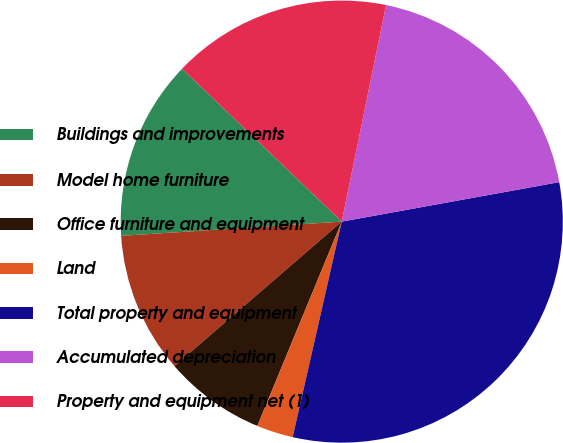<chart> <loc_0><loc_0><loc_500><loc_500><pie_chart><fcel>Buildings and improvements<fcel>Model home furniture<fcel>Office furniture and equipment<fcel>Land<fcel>Total property and equipment<fcel>Accumulated depreciation<fcel>Property and equipment net (1)<nl><fcel>13.18%<fcel>10.31%<fcel>7.43%<fcel>2.67%<fcel>31.42%<fcel>18.93%<fcel>16.06%<nl></chart> 